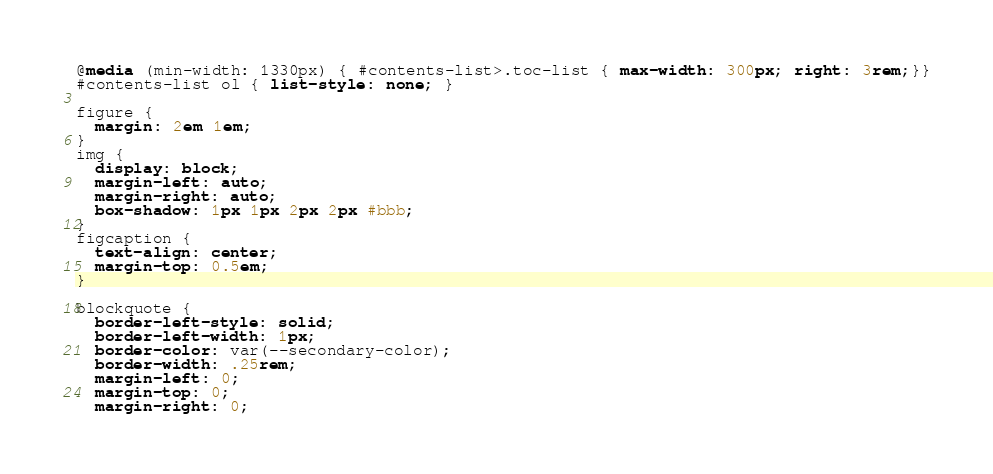Convert code to text. <code><loc_0><loc_0><loc_500><loc_500><_CSS_>@media (min-width: 1330px) { #contents-list>.toc-list { max-width: 300px; right: 3rem;}}
#contents-list ol { list-style: none; }

figure {
  margin: 2em 1em;
}
img { 
  display: block;
  margin-left: auto;
  margin-right: auto;
  box-shadow: 1px 1px 2px 2px #bbb;
}
figcaption { 
  text-align: center;
  margin-top: 0.5em;
}

blockquote {
  border-left-style: solid;
  border-left-width: 1px;
  border-color: var(--secondary-color);
  border-width: .25rem;
  margin-left: 0;
  margin-top: 0;
  margin-right: 0;</code> 